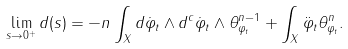Convert formula to latex. <formula><loc_0><loc_0><loc_500><loc_500>\lim _ { s \to 0 ^ { + } } d ( s ) = - n \int _ { X } d \dot { \varphi } _ { t } \wedge d ^ { c } \dot { \varphi } _ { t } \wedge \theta _ { \varphi _ { t } } ^ { n - 1 } + \int _ { X } \ddot { \varphi } _ { t } \theta _ { \varphi _ { t } } ^ { n } .</formula> 